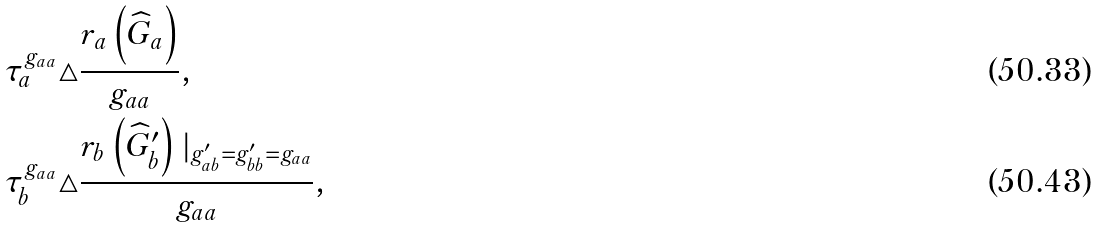<formula> <loc_0><loc_0><loc_500><loc_500>\tau _ { a } ^ { g _ { a a } } \triangle & \frac { r _ { a } \left ( \widehat { G } _ { a } \right ) } { g _ { a a } } , \\ \tau _ { b } ^ { g _ { a a } } \triangle & \frac { r _ { b } \left ( \widehat { G } _ { b } ^ { \prime } \right ) | _ { g _ { a b } ^ { \prime } = g _ { b b } ^ { \prime } = g _ { a a } } } { g _ { a a } } ,</formula> 